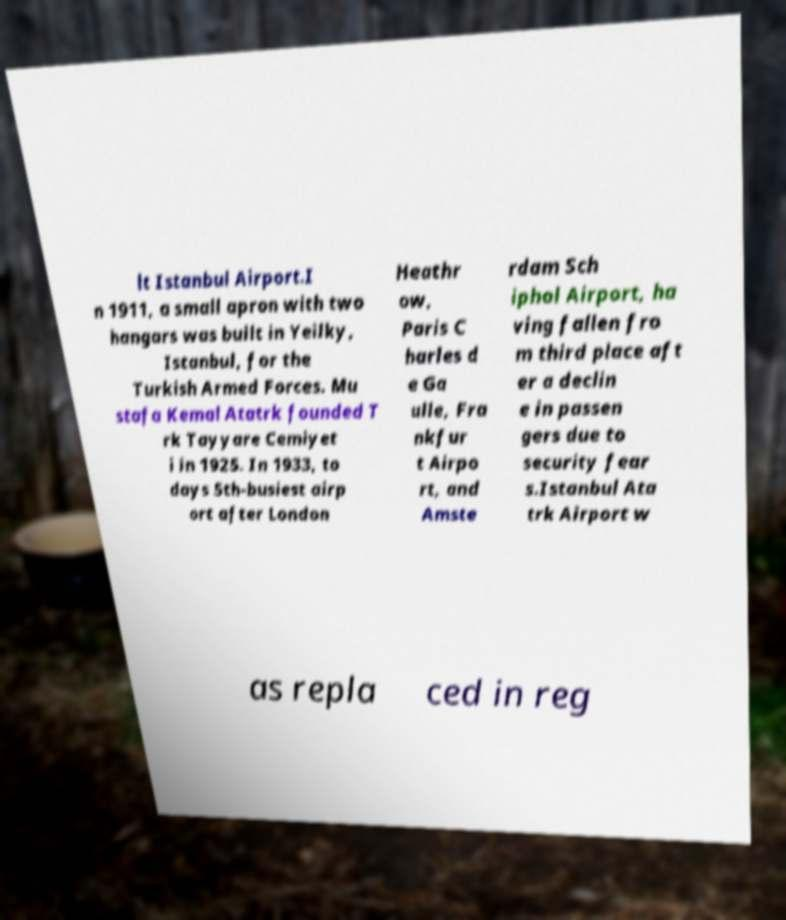What messages or text are displayed in this image? I need them in a readable, typed format. lt Istanbul Airport.I n 1911, a small apron with two hangars was built in Yeilky, Istanbul, for the Turkish Armed Forces. Mu stafa Kemal Atatrk founded T rk Tayyare Cemiyet i in 1925. In 1933, to days 5th-busiest airp ort after London Heathr ow, Paris C harles d e Ga ulle, Fra nkfur t Airpo rt, and Amste rdam Sch iphol Airport, ha ving fallen fro m third place aft er a declin e in passen gers due to security fear s.Istanbul Ata trk Airport w as repla ced in reg 